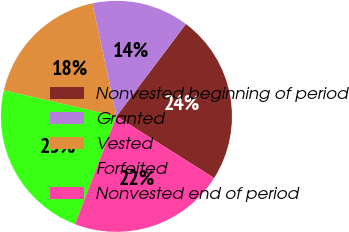<chart> <loc_0><loc_0><loc_500><loc_500><pie_chart><fcel>Nonvested beginning of period<fcel>Granted<fcel>Vested<fcel>Forfeited<fcel>Nonvested end of period<nl><fcel>23.7%<fcel>13.61%<fcel>18.05%<fcel>22.78%<fcel>21.86%<nl></chart> 